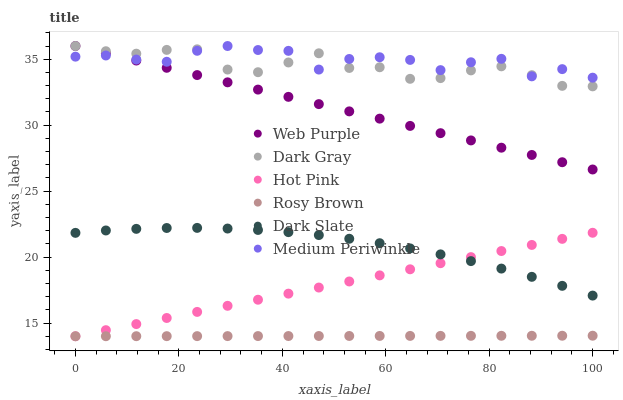Does Rosy Brown have the minimum area under the curve?
Answer yes or no. Yes. Does Medium Periwinkle have the maximum area under the curve?
Answer yes or no. Yes. Does Hot Pink have the minimum area under the curve?
Answer yes or no. No. Does Hot Pink have the maximum area under the curve?
Answer yes or no. No. Is Rosy Brown the smoothest?
Answer yes or no. Yes. Is Medium Periwinkle the roughest?
Answer yes or no. Yes. Is Hot Pink the smoothest?
Answer yes or no. No. Is Hot Pink the roughest?
Answer yes or no. No. Does Rosy Brown have the lowest value?
Answer yes or no. Yes. Does Medium Periwinkle have the lowest value?
Answer yes or no. No. Does Web Purple have the highest value?
Answer yes or no. Yes. Does Hot Pink have the highest value?
Answer yes or no. No. Is Rosy Brown less than Dark Slate?
Answer yes or no. Yes. Is Medium Periwinkle greater than Dark Slate?
Answer yes or no. Yes. Does Dark Gray intersect Medium Periwinkle?
Answer yes or no. Yes. Is Dark Gray less than Medium Periwinkle?
Answer yes or no. No. Is Dark Gray greater than Medium Periwinkle?
Answer yes or no. No. Does Rosy Brown intersect Dark Slate?
Answer yes or no. No. 